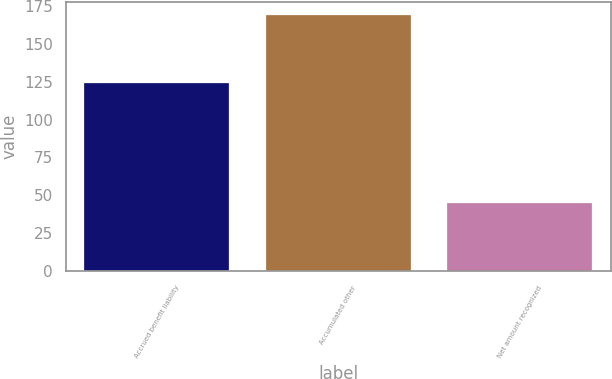Convert chart. <chart><loc_0><loc_0><loc_500><loc_500><bar_chart><fcel>Accrued benefit liability<fcel>Accumulated other<fcel>Net amount recognized<nl><fcel>124.2<fcel>169<fcel>44.8<nl></chart> 